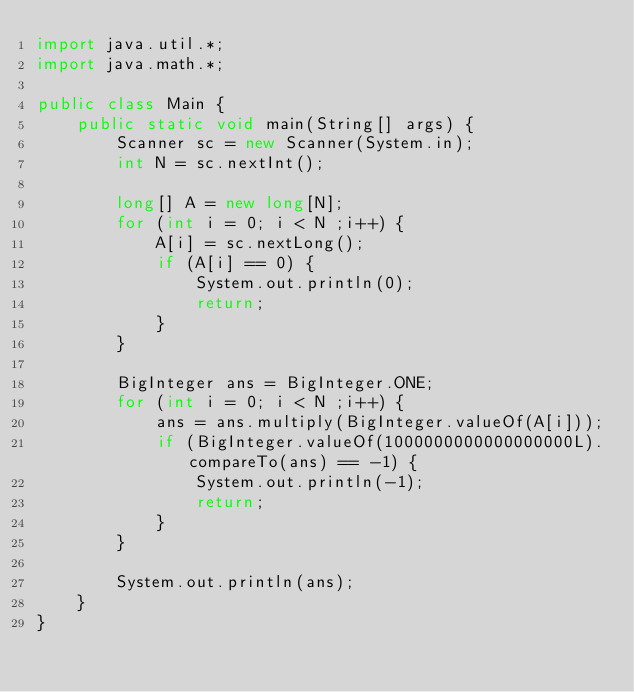Convert code to text. <code><loc_0><loc_0><loc_500><loc_500><_Java_>import java.util.*;
import java.math.*;
 
public class Main {
    public static void main(String[] args) {
        Scanner sc = new Scanner(System.in);
        int N = sc.nextInt();

        long[] A = new long[N];
        for (int i = 0; i < N ;i++) {
            A[i] = sc.nextLong();
            if (A[i] == 0) {
                System.out.println(0);
                return;
            }
        }

        BigInteger ans = BigInteger.ONE;
        for (int i = 0; i < N ;i++) {
            ans = ans.multiply(BigInteger.valueOf(A[i]));
            if (BigInteger.valueOf(1000000000000000000L).compareTo(ans) == -1) {
                System.out.println(-1);
                return;
            }
        }

        System.out.println(ans);
    }
}</code> 